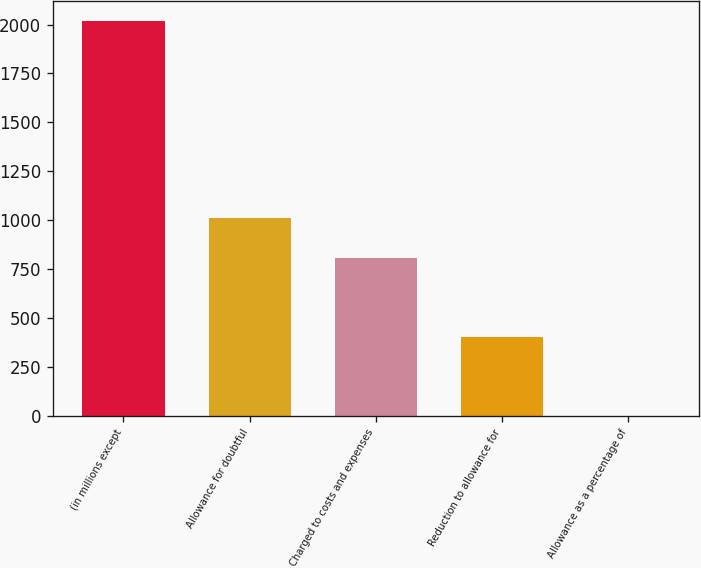Convert chart. <chart><loc_0><loc_0><loc_500><loc_500><bar_chart><fcel>(in millions except<fcel>Allowance for doubtful<fcel>Charged to costs and expenses<fcel>Reduction to allowance for<fcel>Allowance as a percentage of<nl><fcel>2019<fcel>1009.58<fcel>807.69<fcel>403.91<fcel>0.13<nl></chart> 